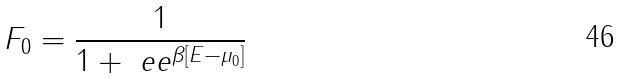<formula> <loc_0><loc_0><loc_500><loc_500>F _ { 0 } = \frac { 1 } { 1 + \ e e ^ { \beta [ E - \mu _ { 0 } ] } }</formula> 